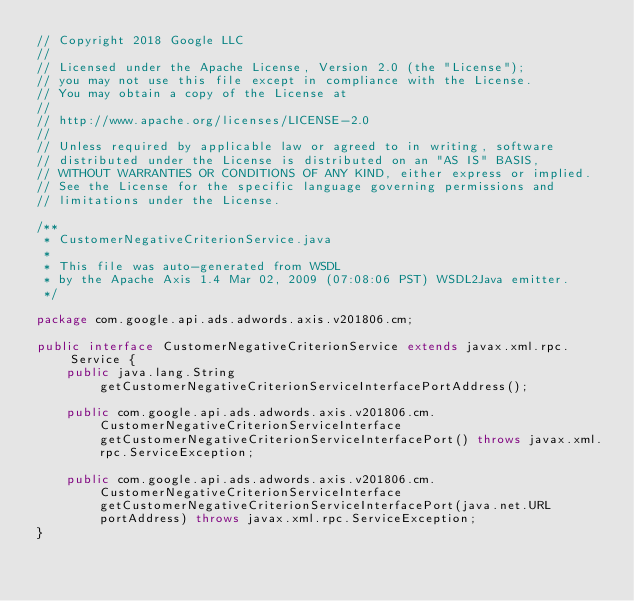<code> <loc_0><loc_0><loc_500><loc_500><_Java_>// Copyright 2018 Google LLC
//
// Licensed under the Apache License, Version 2.0 (the "License");
// you may not use this file except in compliance with the License.
// You may obtain a copy of the License at
//
// http://www.apache.org/licenses/LICENSE-2.0
//
// Unless required by applicable law or agreed to in writing, software
// distributed under the License is distributed on an "AS IS" BASIS,
// WITHOUT WARRANTIES OR CONDITIONS OF ANY KIND, either express or implied.
// See the License for the specific language governing permissions and
// limitations under the License.

/**
 * CustomerNegativeCriterionService.java
 *
 * This file was auto-generated from WSDL
 * by the Apache Axis 1.4 Mar 02, 2009 (07:08:06 PST) WSDL2Java emitter.
 */

package com.google.api.ads.adwords.axis.v201806.cm;

public interface CustomerNegativeCriterionService extends javax.xml.rpc.Service {
    public java.lang.String getCustomerNegativeCriterionServiceInterfacePortAddress();

    public com.google.api.ads.adwords.axis.v201806.cm.CustomerNegativeCriterionServiceInterface getCustomerNegativeCriterionServiceInterfacePort() throws javax.xml.rpc.ServiceException;

    public com.google.api.ads.adwords.axis.v201806.cm.CustomerNegativeCriterionServiceInterface getCustomerNegativeCriterionServiceInterfacePort(java.net.URL portAddress) throws javax.xml.rpc.ServiceException;
}
</code> 